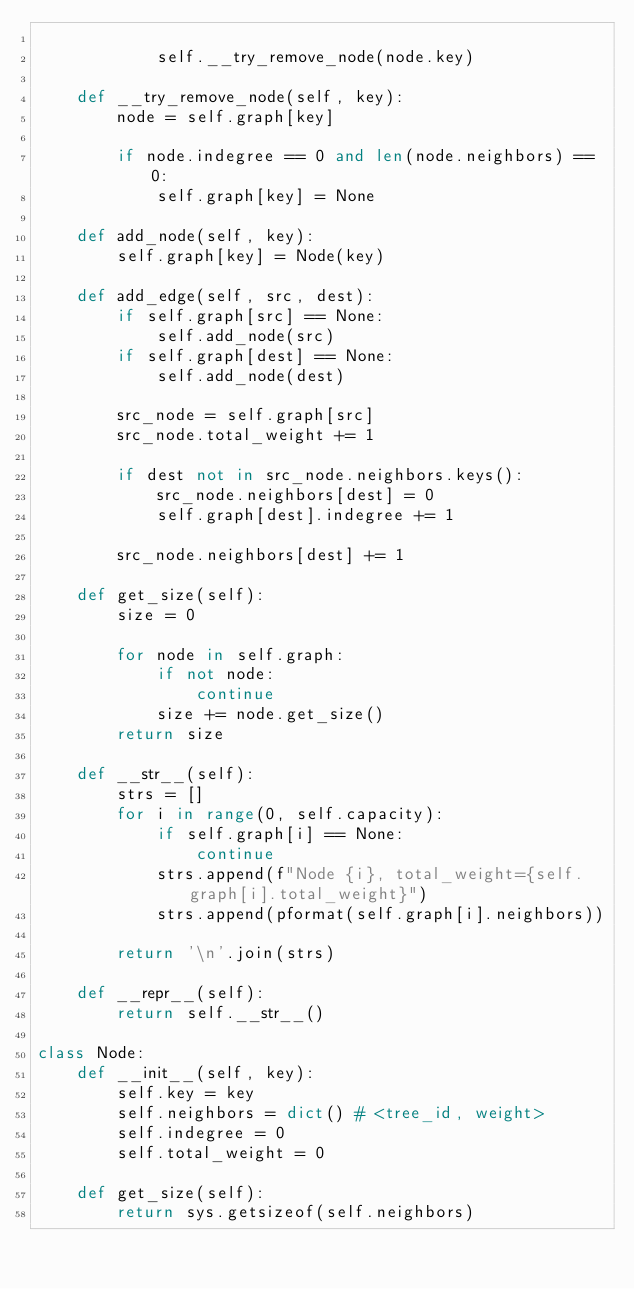Convert code to text. <code><loc_0><loc_0><loc_500><loc_500><_Python_>
            self.__try_remove_node(node.key)

    def __try_remove_node(self, key):
        node = self.graph[key]

        if node.indegree == 0 and len(node.neighbors) == 0:
            self.graph[key] = None

    def add_node(self, key):
        self.graph[key] = Node(key)

    def add_edge(self, src, dest):
        if self.graph[src] == None:
            self.add_node(src)
        if self.graph[dest] == None:
            self.add_node(dest)

        src_node = self.graph[src]
        src_node.total_weight += 1

        if dest not in src_node.neighbors.keys():
            src_node.neighbors[dest] = 0
            self.graph[dest].indegree += 1

        src_node.neighbors[dest] += 1

    def get_size(self):
        size = 0

        for node in self.graph:
            if not node:
                continue
            size += node.get_size()
        return size

    def __str__(self):
        strs = []
        for i in range(0, self.capacity):
            if self.graph[i] == None:
                continue
            strs.append(f"Node {i}, total_weight={self.graph[i].total_weight}")
            strs.append(pformat(self.graph[i].neighbors))

        return '\n'.join(strs)

    def __repr__(self):
        return self.__str__()

class Node:
    def __init__(self, key):
        self.key = key
        self.neighbors = dict() # <tree_id, weight>
        self.indegree = 0
        self.total_weight = 0

    def get_size(self):
        return sys.getsizeof(self.neighbors)
</code> 